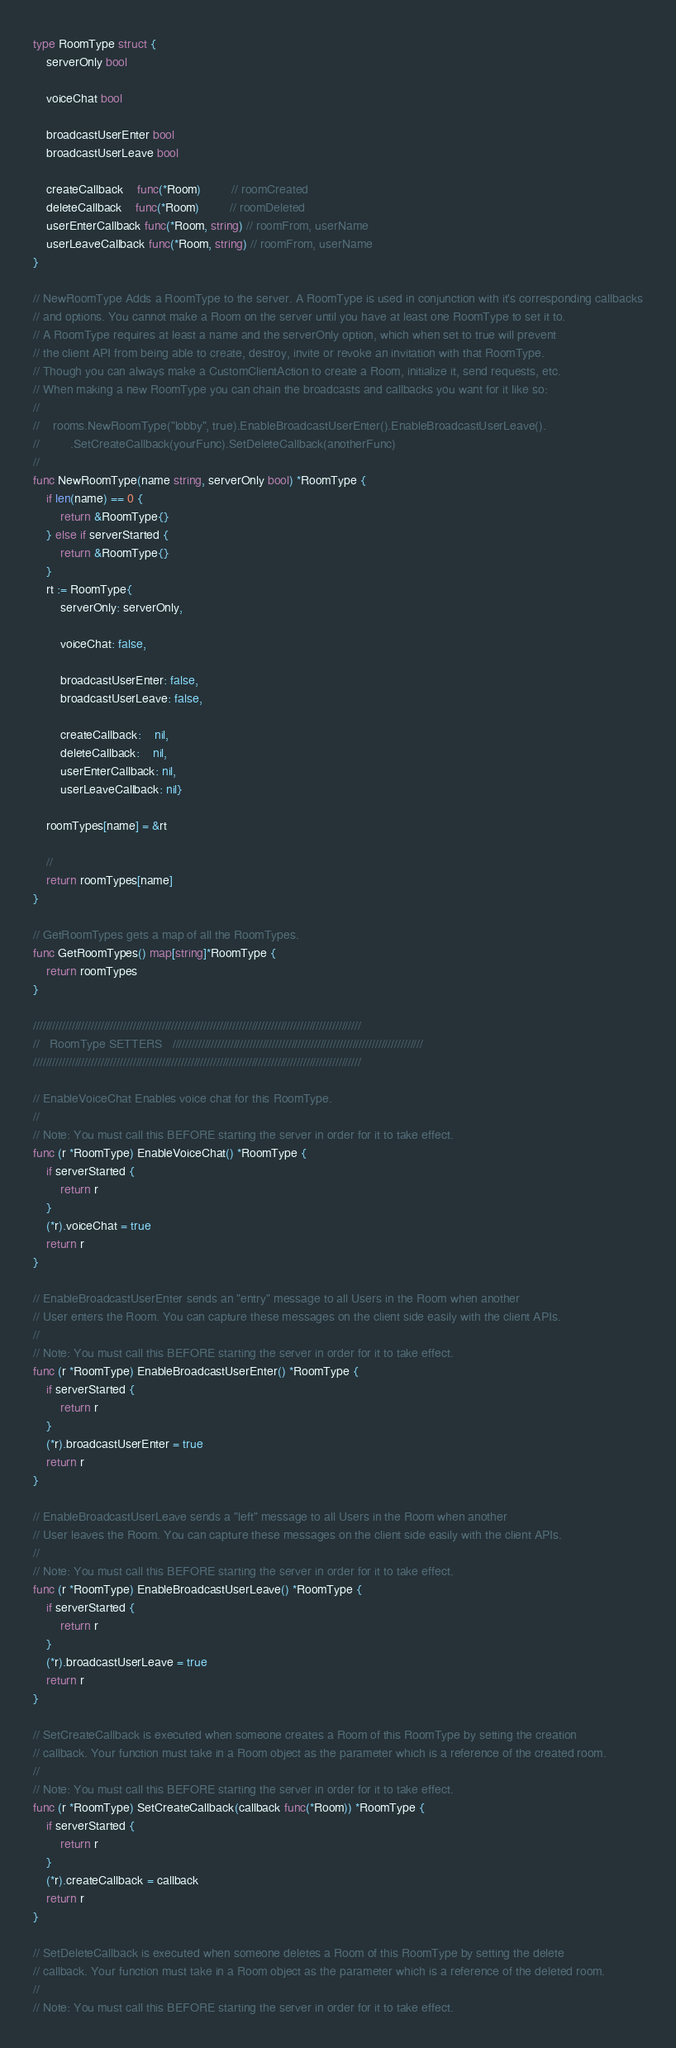<code> <loc_0><loc_0><loc_500><loc_500><_Go_>type RoomType struct {
	serverOnly bool

	voiceChat bool

	broadcastUserEnter bool
	broadcastUserLeave bool

	createCallback    func(*Room)         // roomCreated
	deleteCallback    func(*Room)         // roomDeleted
	userEnterCallback func(*Room, string) // roomFrom, userName
	userLeaveCallback func(*Room, string) // roomFrom, userName
}

// NewRoomType Adds a RoomType to the server. A RoomType is used in conjunction with it's corresponding callbacks
// and options. You cannot make a Room on the server until you have at least one RoomType to set it to.
// A RoomType requires at least a name and the serverOnly option, which when set to true will prevent
// the client API from being able to create, destroy, invite or revoke an invitation with that RoomType.
// Though you can always make a CustomClientAction to create a Room, initialize it, send requests, etc.
// When making a new RoomType you can chain the broadcasts and callbacks you want for it like so:
//
//    rooms.NewRoomType("lobby", true).EnableBroadcastUserEnter().EnableBroadcastUserLeave().
//         .SetCreateCallback(yourFunc).SetDeleteCallback(anotherFunc)
//
func NewRoomType(name string, serverOnly bool) *RoomType {
	if len(name) == 0 {
		return &RoomType{}
	} else if serverStarted {
		return &RoomType{}
	}
	rt := RoomType{
		serverOnly: serverOnly,

		voiceChat: false,

		broadcastUserEnter: false,
		broadcastUserLeave: false,

		createCallback:    nil,
		deleteCallback:    nil,
		userEnterCallback: nil,
		userLeaveCallback: nil}

	roomTypes[name] = &rt

	//
	return roomTypes[name]
}

// GetRoomTypes gets a map of all the RoomTypes.
func GetRoomTypes() map[string]*RoomType {
	return roomTypes
}

//////////////////////////////////////////////////////////////////////////////////////////////////////
//   RoomType SETTERS   //////////////////////////////////////////////////////////////////////////////
//////////////////////////////////////////////////////////////////////////////////////////////////////

// EnableVoiceChat Enables voice chat for this RoomType.
//
// Note: You must call this BEFORE starting the server in order for it to take effect.
func (r *RoomType) EnableVoiceChat() *RoomType {
	if serverStarted {
		return r
	}
	(*r).voiceChat = true
	return r
}

// EnableBroadcastUserEnter sends an "entry" message to all Users in the Room when another
// User enters the Room. You can capture these messages on the client side easily with the client APIs.
//
// Note: You must call this BEFORE starting the server in order for it to take effect.
func (r *RoomType) EnableBroadcastUserEnter() *RoomType {
	if serverStarted {
		return r
	}
	(*r).broadcastUserEnter = true
	return r
}

// EnableBroadcastUserLeave sends a "left" message to all Users in the Room when another
// User leaves the Room. You can capture these messages on the client side easily with the client APIs.
//
// Note: You must call this BEFORE starting the server in order for it to take effect.
func (r *RoomType) EnableBroadcastUserLeave() *RoomType {
	if serverStarted {
		return r
	}
	(*r).broadcastUserLeave = true
	return r
}

// SetCreateCallback is executed when someone creates a Room of this RoomType by setting the creation
// callback. Your function must take in a Room object as the parameter which is a reference of the created room.
//
// Note: You must call this BEFORE starting the server in order for it to take effect.
func (r *RoomType) SetCreateCallback(callback func(*Room)) *RoomType {
	if serverStarted {
		return r
	}
	(*r).createCallback = callback
	return r
}

// SetDeleteCallback is executed when someone deletes a Room of this RoomType by setting the delete
// callback. Your function must take in a Room object as the parameter which is a reference of the deleted room.
//
// Note: You must call this BEFORE starting the server in order for it to take effect.</code> 